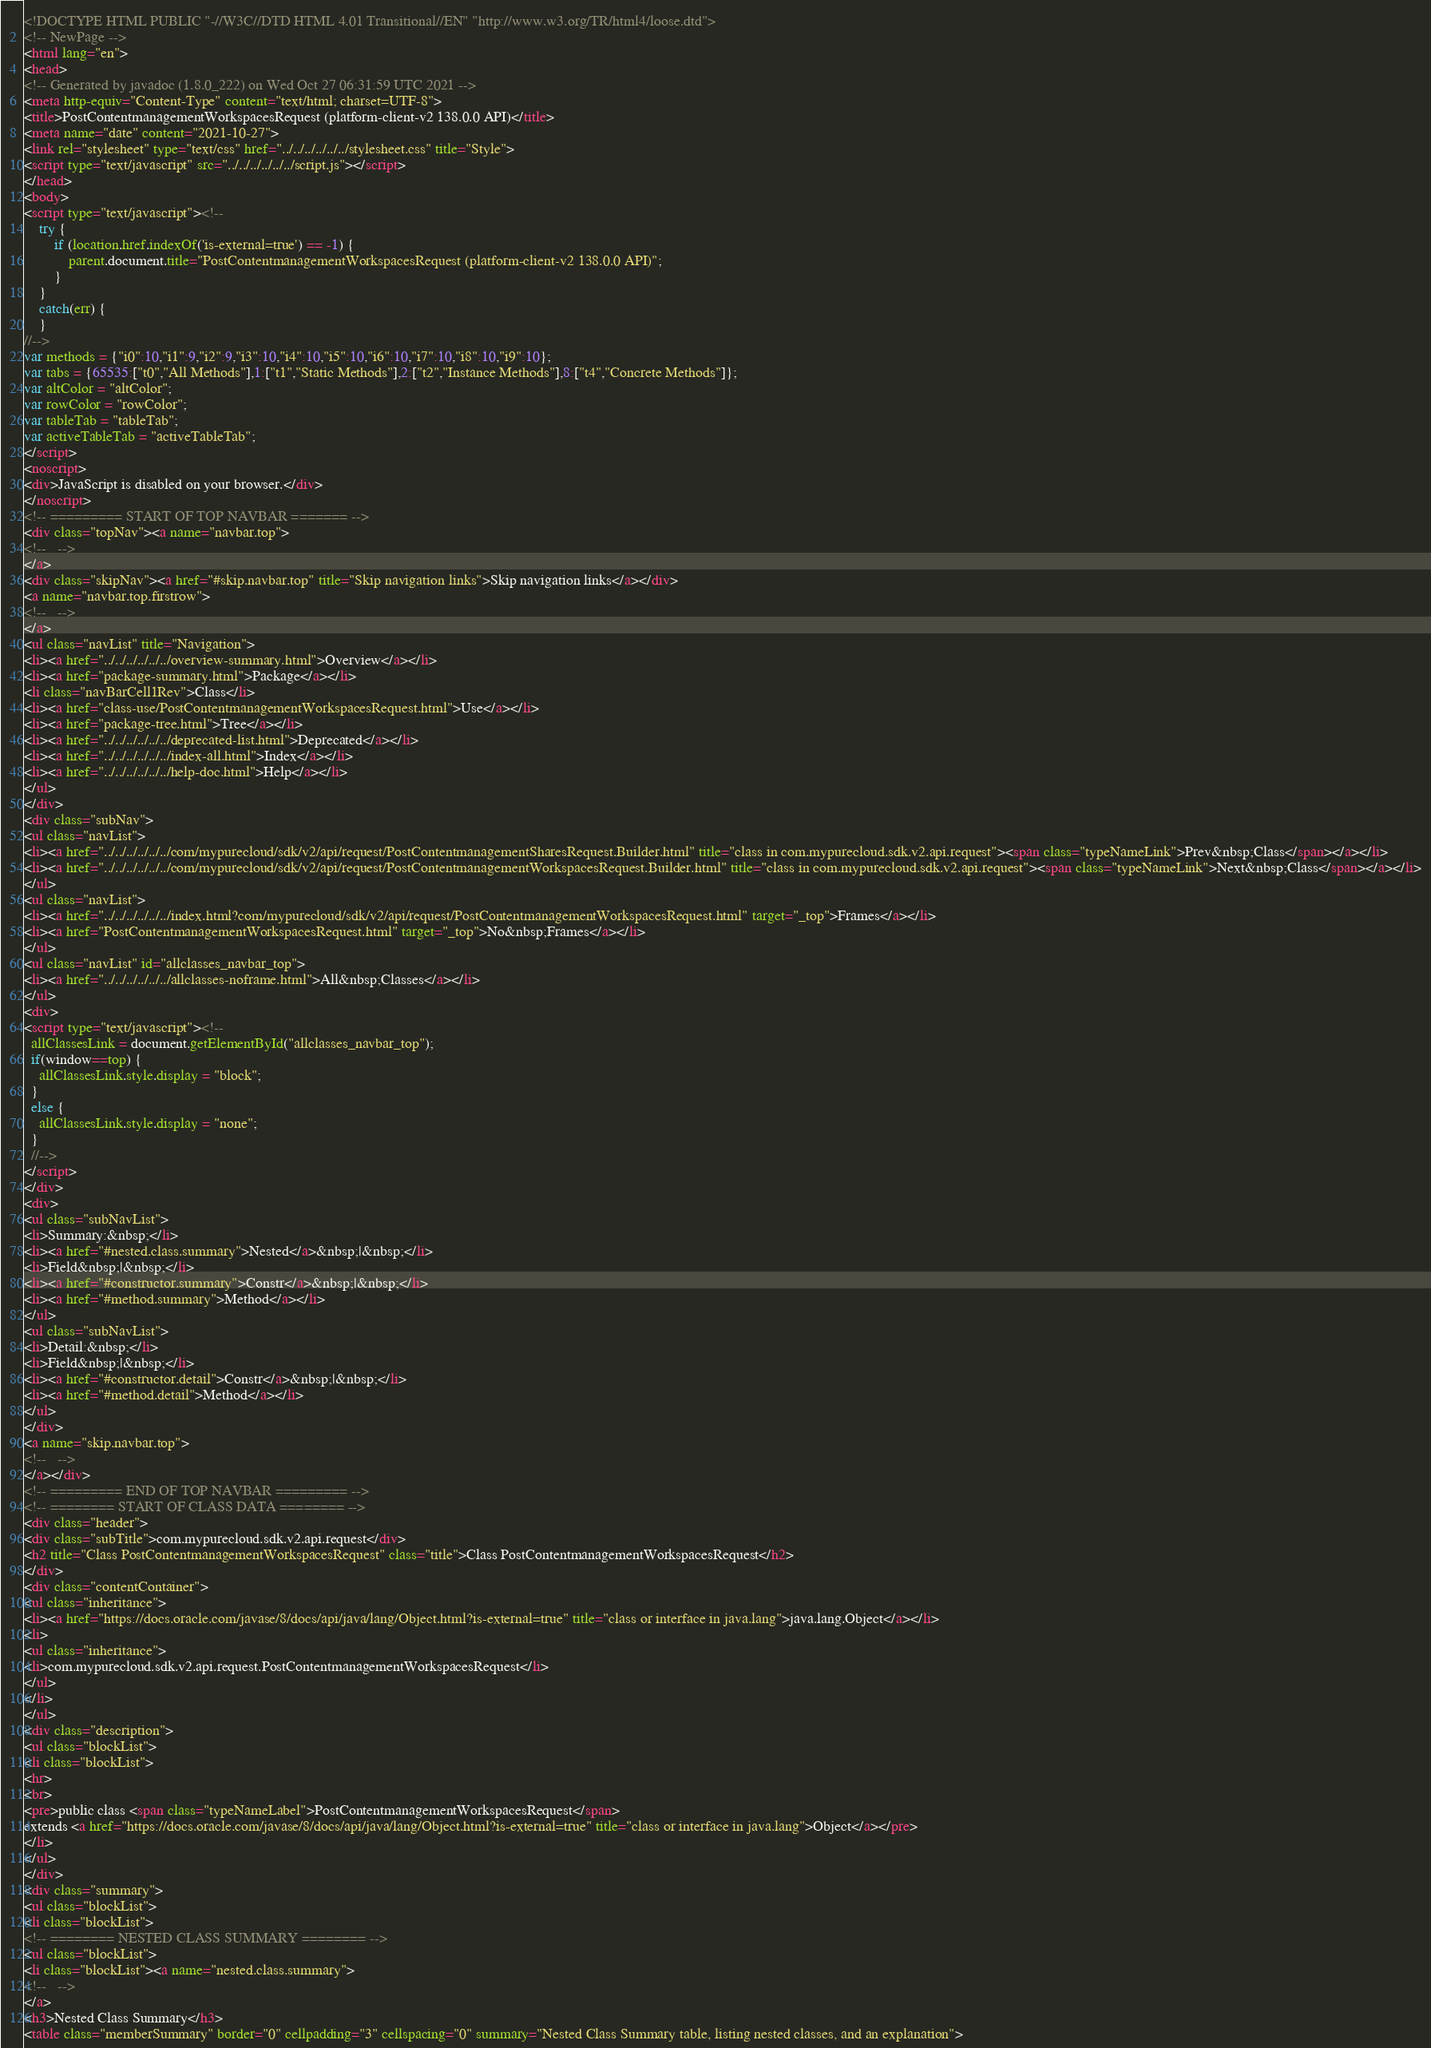Convert code to text. <code><loc_0><loc_0><loc_500><loc_500><_HTML_><!DOCTYPE HTML PUBLIC "-//W3C//DTD HTML 4.01 Transitional//EN" "http://www.w3.org/TR/html4/loose.dtd">
<!-- NewPage -->
<html lang="en">
<head>
<!-- Generated by javadoc (1.8.0_222) on Wed Oct 27 06:31:59 UTC 2021 -->
<meta http-equiv="Content-Type" content="text/html; charset=UTF-8">
<title>PostContentmanagementWorkspacesRequest (platform-client-v2 138.0.0 API)</title>
<meta name="date" content="2021-10-27">
<link rel="stylesheet" type="text/css" href="../../../../../../stylesheet.css" title="Style">
<script type="text/javascript" src="../../../../../../script.js"></script>
</head>
<body>
<script type="text/javascript"><!--
    try {
        if (location.href.indexOf('is-external=true') == -1) {
            parent.document.title="PostContentmanagementWorkspacesRequest (platform-client-v2 138.0.0 API)";
        }
    }
    catch(err) {
    }
//-->
var methods = {"i0":10,"i1":9,"i2":9,"i3":10,"i4":10,"i5":10,"i6":10,"i7":10,"i8":10,"i9":10};
var tabs = {65535:["t0","All Methods"],1:["t1","Static Methods"],2:["t2","Instance Methods"],8:["t4","Concrete Methods"]};
var altColor = "altColor";
var rowColor = "rowColor";
var tableTab = "tableTab";
var activeTableTab = "activeTableTab";
</script>
<noscript>
<div>JavaScript is disabled on your browser.</div>
</noscript>
<!-- ========= START OF TOP NAVBAR ======= -->
<div class="topNav"><a name="navbar.top">
<!--   -->
</a>
<div class="skipNav"><a href="#skip.navbar.top" title="Skip navigation links">Skip navigation links</a></div>
<a name="navbar.top.firstrow">
<!--   -->
</a>
<ul class="navList" title="Navigation">
<li><a href="../../../../../../overview-summary.html">Overview</a></li>
<li><a href="package-summary.html">Package</a></li>
<li class="navBarCell1Rev">Class</li>
<li><a href="class-use/PostContentmanagementWorkspacesRequest.html">Use</a></li>
<li><a href="package-tree.html">Tree</a></li>
<li><a href="../../../../../../deprecated-list.html">Deprecated</a></li>
<li><a href="../../../../../../index-all.html">Index</a></li>
<li><a href="../../../../../../help-doc.html">Help</a></li>
</ul>
</div>
<div class="subNav">
<ul class="navList">
<li><a href="../../../../../../com/mypurecloud/sdk/v2/api/request/PostContentmanagementSharesRequest.Builder.html" title="class in com.mypurecloud.sdk.v2.api.request"><span class="typeNameLink">Prev&nbsp;Class</span></a></li>
<li><a href="../../../../../../com/mypurecloud/sdk/v2/api/request/PostContentmanagementWorkspacesRequest.Builder.html" title="class in com.mypurecloud.sdk.v2.api.request"><span class="typeNameLink">Next&nbsp;Class</span></a></li>
</ul>
<ul class="navList">
<li><a href="../../../../../../index.html?com/mypurecloud/sdk/v2/api/request/PostContentmanagementWorkspacesRequest.html" target="_top">Frames</a></li>
<li><a href="PostContentmanagementWorkspacesRequest.html" target="_top">No&nbsp;Frames</a></li>
</ul>
<ul class="navList" id="allclasses_navbar_top">
<li><a href="../../../../../../allclasses-noframe.html">All&nbsp;Classes</a></li>
</ul>
<div>
<script type="text/javascript"><!--
  allClassesLink = document.getElementById("allclasses_navbar_top");
  if(window==top) {
    allClassesLink.style.display = "block";
  }
  else {
    allClassesLink.style.display = "none";
  }
  //-->
</script>
</div>
<div>
<ul class="subNavList">
<li>Summary:&nbsp;</li>
<li><a href="#nested.class.summary">Nested</a>&nbsp;|&nbsp;</li>
<li>Field&nbsp;|&nbsp;</li>
<li><a href="#constructor.summary">Constr</a>&nbsp;|&nbsp;</li>
<li><a href="#method.summary">Method</a></li>
</ul>
<ul class="subNavList">
<li>Detail:&nbsp;</li>
<li>Field&nbsp;|&nbsp;</li>
<li><a href="#constructor.detail">Constr</a>&nbsp;|&nbsp;</li>
<li><a href="#method.detail">Method</a></li>
</ul>
</div>
<a name="skip.navbar.top">
<!--   -->
</a></div>
<!-- ========= END OF TOP NAVBAR ========= -->
<!-- ======== START OF CLASS DATA ======== -->
<div class="header">
<div class="subTitle">com.mypurecloud.sdk.v2.api.request</div>
<h2 title="Class PostContentmanagementWorkspacesRequest" class="title">Class PostContentmanagementWorkspacesRequest</h2>
</div>
<div class="contentContainer">
<ul class="inheritance">
<li><a href="https://docs.oracle.com/javase/8/docs/api/java/lang/Object.html?is-external=true" title="class or interface in java.lang">java.lang.Object</a></li>
<li>
<ul class="inheritance">
<li>com.mypurecloud.sdk.v2.api.request.PostContentmanagementWorkspacesRequest</li>
</ul>
</li>
</ul>
<div class="description">
<ul class="blockList">
<li class="blockList">
<hr>
<br>
<pre>public class <span class="typeNameLabel">PostContentmanagementWorkspacesRequest</span>
extends <a href="https://docs.oracle.com/javase/8/docs/api/java/lang/Object.html?is-external=true" title="class or interface in java.lang">Object</a></pre>
</li>
</ul>
</div>
<div class="summary">
<ul class="blockList">
<li class="blockList">
<!-- ======== NESTED CLASS SUMMARY ======== -->
<ul class="blockList">
<li class="blockList"><a name="nested.class.summary">
<!--   -->
</a>
<h3>Nested Class Summary</h3>
<table class="memberSummary" border="0" cellpadding="3" cellspacing="0" summary="Nested Class Summary table, listing nested classes, and an explanation"></code> 